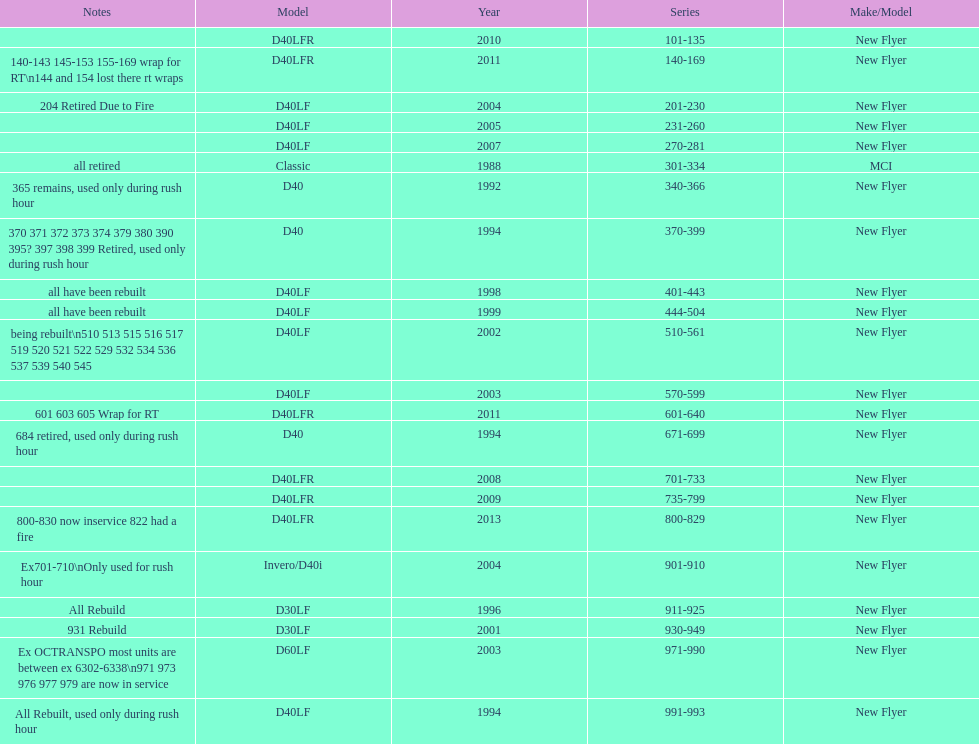Which buses are the newest in the current fleet? 800-829. 